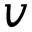<formula> <loc_0><loc_0><loc_500><loc_500>v</formula> 